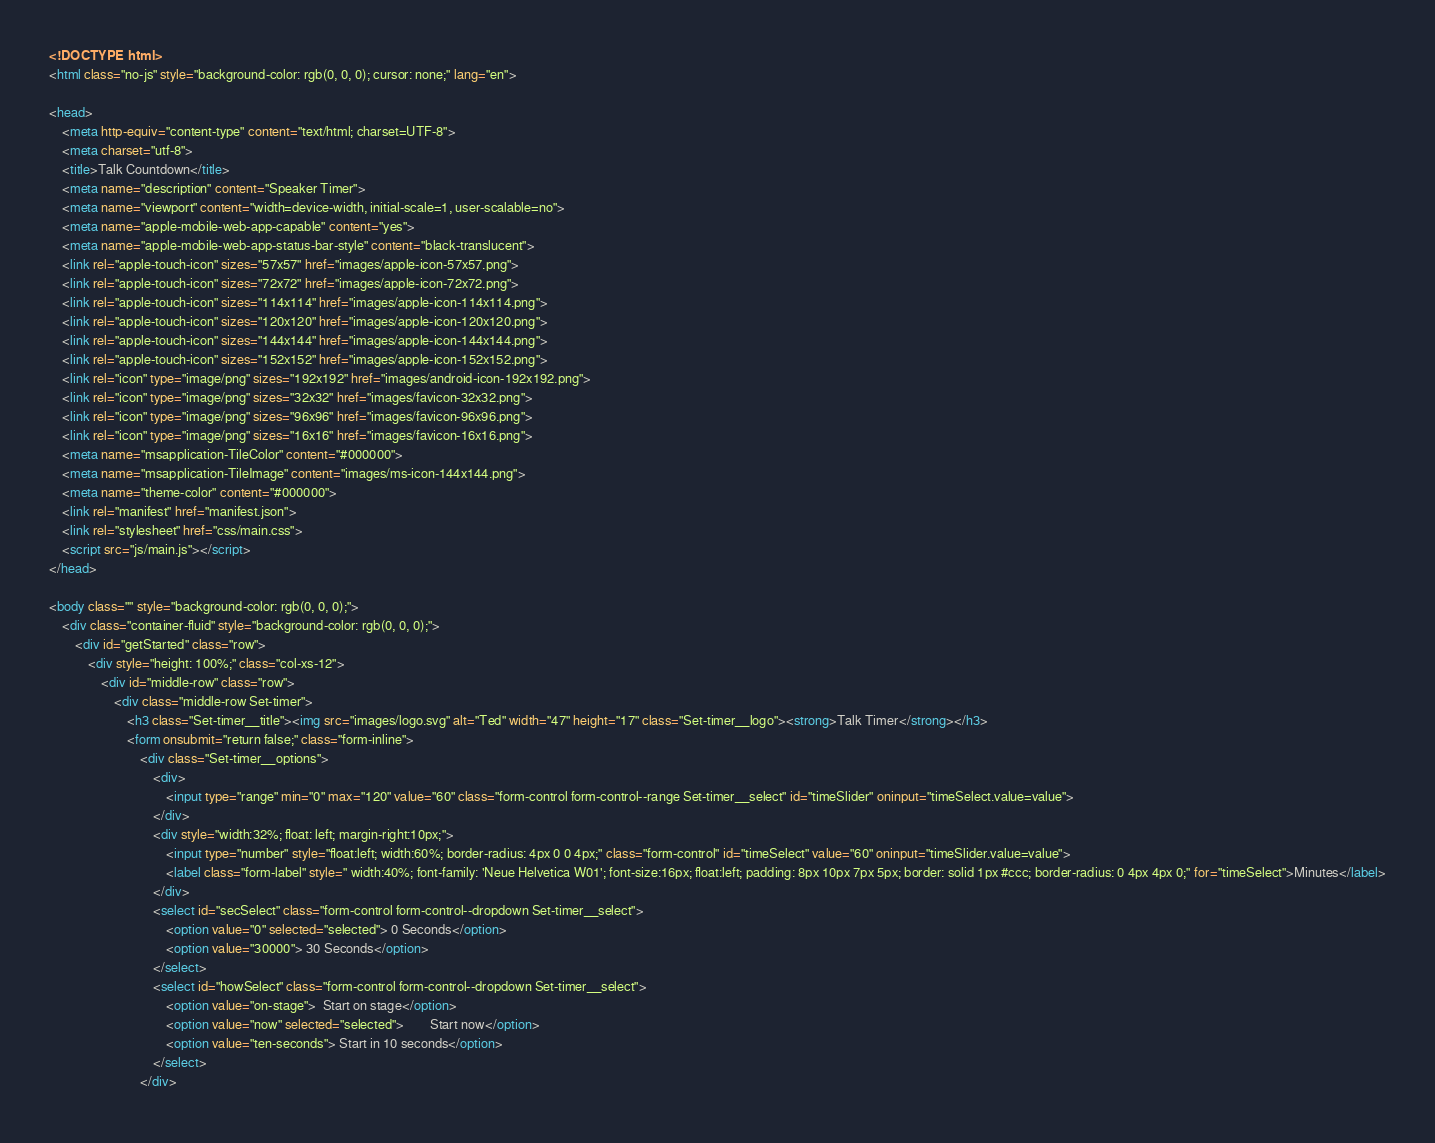<code> <loc_0><loc_0><loc_500><loc_500><_HTML_><!DOCTYPE html>
<html class="no-js" style="background-color: rgb(0, 0, 0); cursor: none;" lang="en">

<head>
    <meta http-equiv="content-type" content="text/html; charset=UTF-8">
    <meta charset="utf-8">
    <title>Talk Countdown</title>
    <meta name="description" content="Speaker Timer">
    <meta name="viewport" content="width=device-width, initial-scale=1, user-scalable=no">
    <meta name="apple-mobile-web-app-capable" content="yes">
    <meta name="apple-mobile-web-app-status-bar-style" content="black-translucent">
    <link rel="apple-touch-icon" sizes="57x57" href="images/apple-icon-57x57.png">
    <link rel="apple-touch-icon" sizes="72x72" href="images/apple-icon-72x72.png">
    <link rel="apple-touch-icon" sizes="114x114" href="images/apple-icon-114x114.png">
    <link rel="apple-touch-icon" sizes="120x120" href="images/apple-icon-120x120.png">
    <link rel="apple-touch-icon" sizes="144x144" href="images/apple-icon-144x144.png">
    <link rel="apple-touch-icon" sizes="152x152" href="images/apple-icon-152x152.png">
    <link rel="icon" type="image/png" sizes="192x192" href="images/android-icon-192x192.png">
    <link rel="icon" type="image/png" sizes="32x32" href="images/favicon-32x32.png">
    <link rel="icon" type="image/png" sizes="96x96" href="images/favicon-96x96.png">
    <link rel="icon" type="image/png" sizes="16x16" href="images/favicon-16x16.png">
    <meta name="msapplication-TileColor" content="#000000">
    <meta name="msapplication-TileImage" content="images/ms-icon-144x144.png">
    <meta name="theme-color" content="#000000">
    <link rel="manifest" href="manifest.json">
    <link rel="stylesheet" href="css/main.css">
    <script src="js/main.js"></script>
</head>

<body class="" style="background-color: rgb(0, 0, 0);">
    <div class="container-fluid" style="background-color: rgb(0, 0, 0);">
        <div id="getStarted" class="row">
            <div style="height: 100%;" class="col-xs-12">
                <div id="middle-row" class="row">
                    <div class="middle-row Set-timer">
                        <h3 class="Set-timer__title"><img src="images/logo.svg" alt="Ted" width="47" height="17" class="Set-timer__logo"><strong>Talk Timer</strong></h3>
                        <form onsubmit="return false;" class="form-inline">
                            <div class="Set-timer__options">
                                <div>
                                    <input type="range" min="0" max="120" value="60" class="form-control form-control--range Set-timer__select" id="timeSlider" oninput="timeSelect.value=value">
                                </div>
                                <div style="width:32%; float: left; margin-right:10px;">
                                    <input type="number" style="float:left; width:60%; border-radius: 4px 0 0 4px;" class="form-control" id="timeSelect" value="60" oninput="timeSlider.value=value">
                                    <label class="form-label" style=" width:40%; font-family: 'Neue Helvetica W01'; font-size:16px; float:left; padding: 8px 10px 7px 5px; border: solid 1px #ccc; border-radius: 0 4px 4px 0;" for="timeSelect">Minutes</label>
                                </div>
                                <select id="secSelect" class="form-control form-control--dropdown Set-timer__select">
                                    <option value="0" selected="selected"> 0 Seconds</option>
                                    <option value="30000"> 30 Seconds</option>
                                </select>
                                <select id="howSelect" class="form-control form-control--dropdown Set-timer__select">
                                    <option value="on-stage">  Start on stage</option>
                                    <option value="now" selected="selected">        Start now</option>
                                    <option value="ten-seconds"> Start in 10 seconds</option>
                                </select>
                            </div></code> 